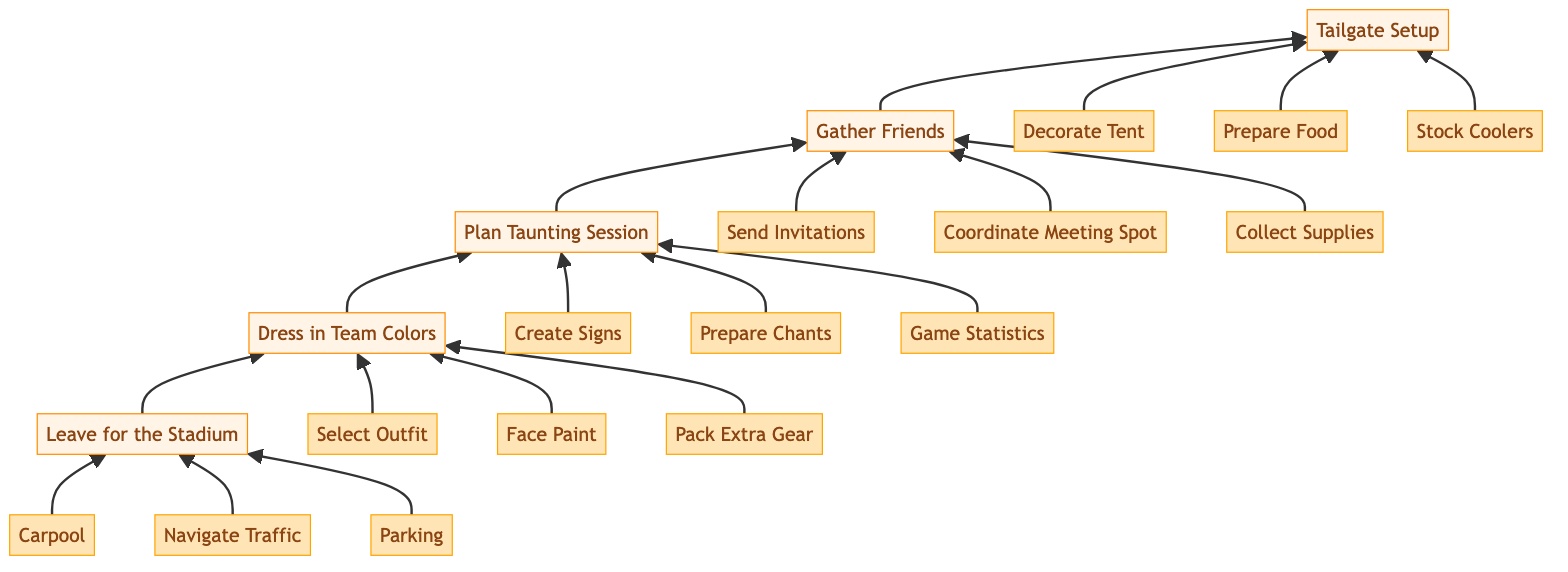What is the starting point of this flowchart? The flowchart starts with the node "Leave for the Stadium," which is at the bottom of the diagram. This initiates the series of steps to prepare for game day.
Answer: Leave for the Stadium How many main preparation steps are there? The flowchart includes five main steps: "Leave for the Stadium," "Dress in Team Colors," "Plan Taunting Session," "Gather Friends," and "Tailgate Setup." Counting these gives us five distinct main preparation steps.
Answer: 5 What is the immediate next step after "Gather Friends"? The flowchart indicates that "Gather Friends" is followed by "Tailgate Setup," showing the progression from inviting friends to setting up for the tailgate.
Answer: Tailgate Setup Which step involves creating humorous signs? In the "Plan Taunting Session" section, the step "Create Signs" specifically involves making humorous signs to taunt Aggies fans. This emphasizes the friendly rivalry aspect.
Answer: Create Signs How many steps are involved in "Dress in Team Colors"? The "Dress in Team Colors" includes three specific steps: "Select Outfit," "Face Paint," and "Pack Extra Gear." Counting these steps leads to three activities to support the Longhorns.
Answer: 3 What step directly follows "Leave for the Stadium"? The step that directly follows "Leave for the Stadium" in the flowchart is "Dress in Team Colors," indicating the importance of showing team spirit right before heading out.
Answer: Dress in Team Colors Which preparation step involves food preparation? The "Tailgate Setup" step describes the action "Prepare Food," which focuses on cooking barbecue and setting up a snack table for the tailgate event.
Answer: Prepare Food What is the last step in the flowchart? The flowchart flows upward to conclude with "Tailgate Setup," making it the final step in the preparation process for game day activities.
Answer: Tailgate Setup How many steps are required to "Navigate Traffic"? The step "Navigate Traffic" is found under "Leave for the Stadium," which is one of three steps in this section. Thus, only one step is specifically focused on traffic.
Answer: 1 